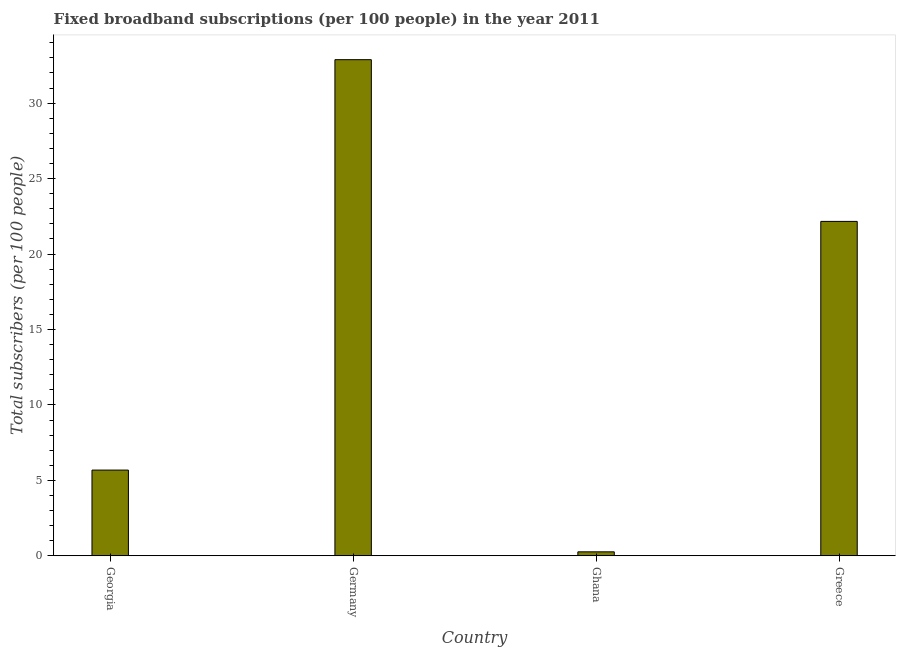Does the graph contain any zero values?
Give a very brief answer. No. Does the graph contain grids?
Offer a very short reply. No. What is the title of the graph?
Keep it short and to the point. Fixed broadband subscriptions (per 100 people) in the year 2011. What is the label or title of the X-axis?
Your response must be concise. Country. What is the label or title of the Y-axis?
Your answer should be compact. Total subscribers (per 100 people). What is the total number of fixed broadband subscriptions in Georgia?
Your answer should be very brief. 5.68. Across all countries, what is the maximum total number of fixed broadband subscriptions?
Keep it short and to the point. 32.88. Across all countries, what is the minimum total number of fixed broadband subscriptions?
Make the answer very short. 0.26. What is the sum of the total number of fixed broadband subscriptions?
Ensure brevity in your answer.  60.99. What is the difference between the total number of fixed broadband subscriptions in Georgia and Germany?
Provide a short and direct response. -27.2. What is the average total number of fixed broadband subscriptions per country?
Provide a short and direct response. 15.25. What is the median total number of fixed broadband subscriptions?
Provide a short and direct response. 13.92. In how many countries, is the total number of fixed broadband subscriptions greater than 29 ?
Offer a very short reply. 1. What is the ratio of the total number of fixed broadband subscriptions in Georgia to that in Germany?
Ensure brevity in your answer.  0.17. Is the difference between the total number of fixed broadband subscriptions in Georgia and Germany greater than the difference between any two countries?
Your answer should be compact. No. What is the difference between the highest and the second highest total number of fixed broadband subscriptions?
Keep it short and to the point. 10.72. Is the sum of the total number of fixed broadband subscriptions in Ghana and Greece greater than the maximum total number of fixed broadband subscriptions across all countries?
Offer a terse response. No. What is the difference between the highest and the lowest total number of fixed broadband subscriptions?
Give a very brief answer. 32.62. How many countries are there in the graph?
Keep it short and to the point. 4. What is the difference between two consecutive major ticks on the Y-axis?
Make the answer very short. 5. What is the Total subscribers (per 100 people) in Georgia?
Provide a short and direct response. 5.68. What is the Total subscribers (per 100 people) in Germany?
Give a very brief answer. 32.88. What is the Total subscribers (per 100 people) in Ghana?
Your answer should be compact. 0.26. What is the Total subscribers (per 100 people) of Greece?
Your answer should be very brief. 22.16. What is the difference between the Total subscribers (per 100 people) in Georgia and Germany?
Provide a short and direct response. -27.2. What is the difference between the Total subscribers (per 100 people) in Georgia and Ghana?
Provide a short and direct response. 5.42. What is the difference between the Total subscribers (per 100 people) in Georgia and Greece?
Provide a short and direct response. -16.48. What is the difference between the Total subscribers (per 100 people) in Germany and Ghana?
Provide a succinct answer. 32.62. What is the difference between the Total subscribers (per 100 people) in Germany and Greece?
Your response must be concise. 10.72. What is the difference between the Total subscribers (per 100 people) in Ghana and Greece?
Your answer should be very brief. -21.9. What is the ratio of the Total subscribers (per 100 people) in Georgia to that in Germany?
Your answer should be compact. 0.17. What is the ratio of the Total subscribers (per 100 people) in Georgia to that in Ghana?
Make the answer very short. 21.64. What is the ratio of the Total subscribers (per 100 people) in Georgia to that in Greece?
Keep it short and to the point. 0.26. What is the ratio of the Total subscribers (per 100 people) in Germany to that in Ghana?
Offer a very short reply. 125.28. What is the ratio of the Total subscribers (per 100 people) in Germany to that in Greece?
Ensure brevity in your answer.  1.48. What is the ratio of the Total subscribers (per 100 people) in Ghana to that in Greece?
Your answer should be compact. 0.01. 